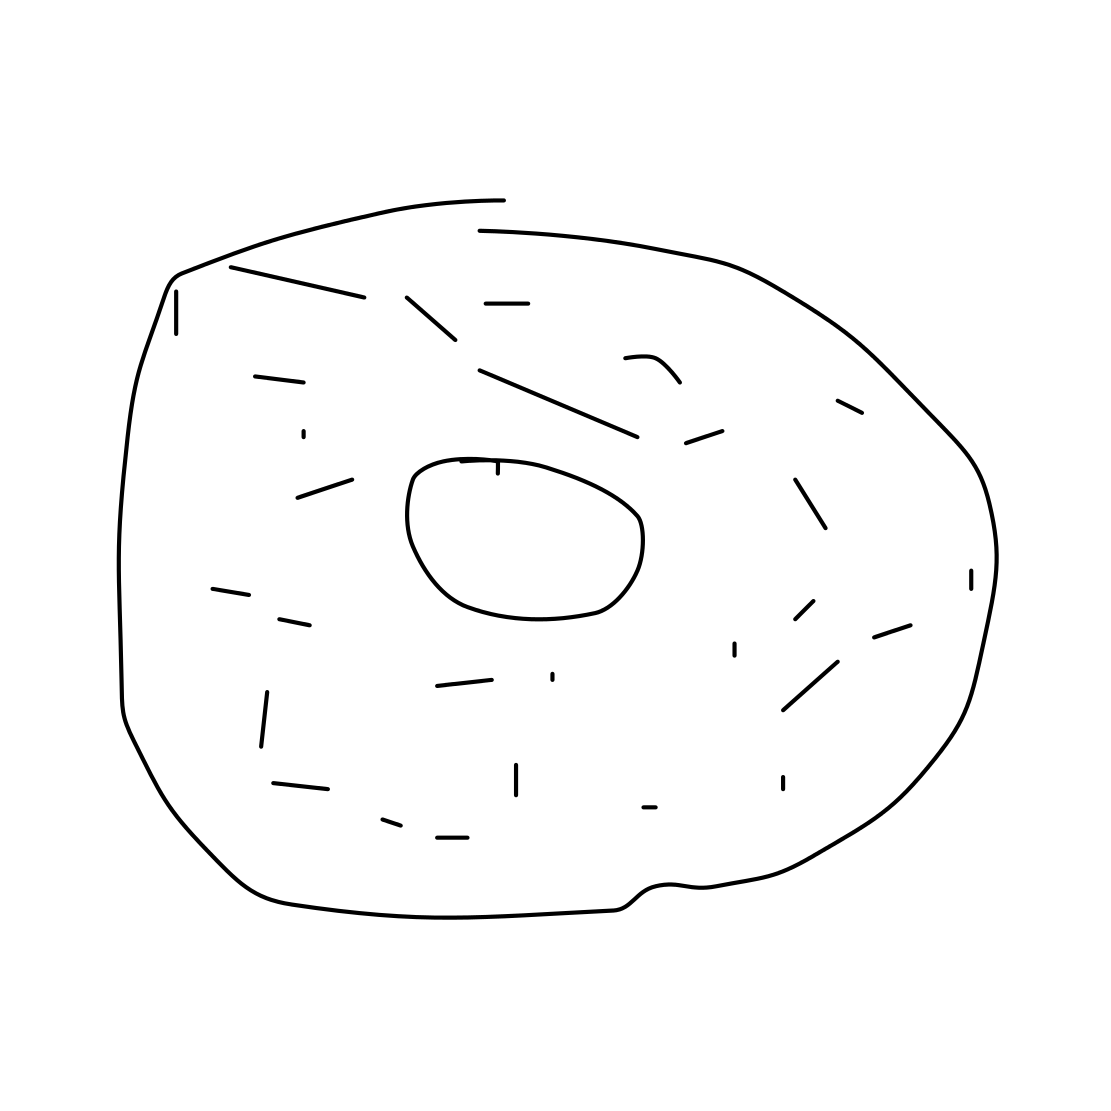Is this a donut in the image? Yes, the image illustrates what appears to be a simple line drawing of a donut. It's a classic ring shape with a hole in the center, typical of donuts, depicted in a minimalistic style. 